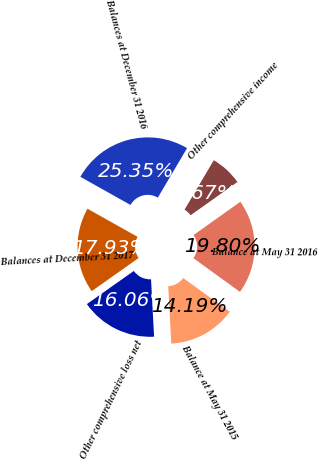<chart> <loc_0><loc_0><loc_500><loc_500><pie_chart><fcel>Other comprehensive loss net<fcel>Balance at May 31 2015<fcel>Balance at May 31 2016<fcel>Other comprehensive income<fcel>Balances at December 31 2016<fcel>Balances at December 31 2017<nl><fcel>16.06%<fcel>14.19%<fcel>19.8%<fcel>6.67%<fcel>25.35%<fcel>17.93%<nl></chart> 